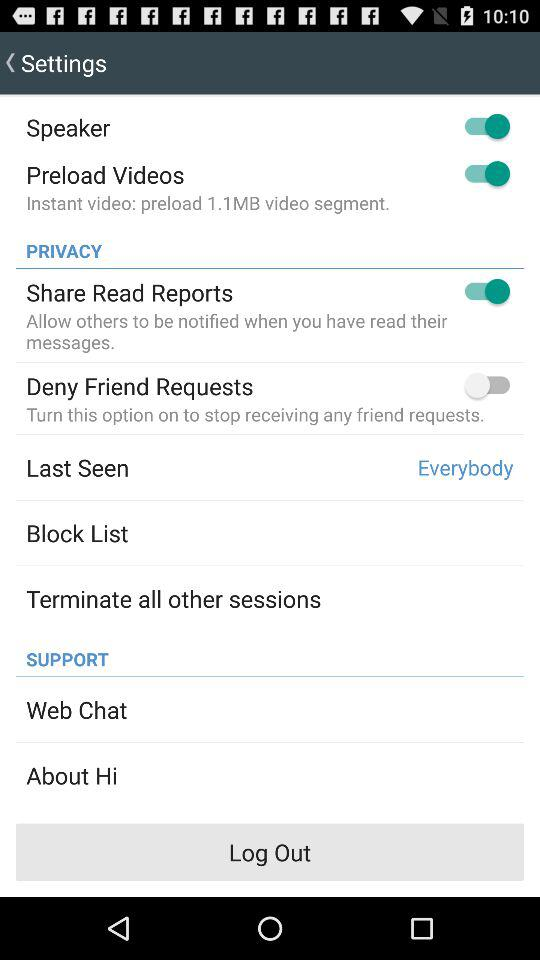What is the status of the "Deny Friend Requests"? The status is "off". 